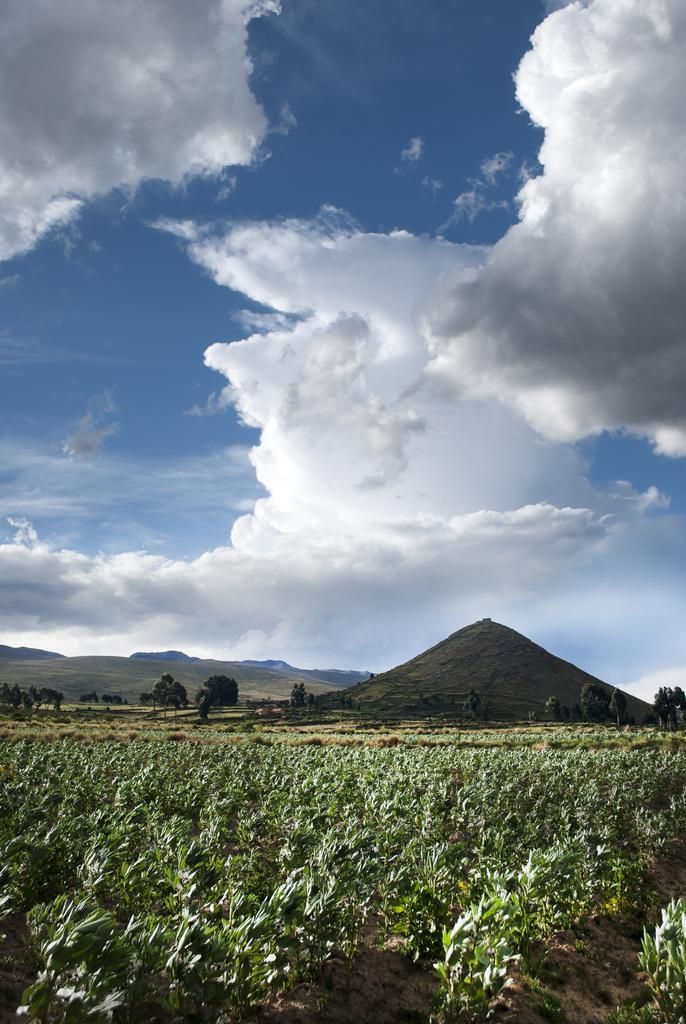What type of landscape is depicted in the image? The image features hills. What type of vegetation can be seen in the image? There are trees and plants in the image. What is visible in the sky at the top of the image? There are clouds in the sky at the top of the image. What type of joke is being told by the boy in the image? There is no boy present in the image, and therefore no joke being told. What color is the boy's hair in the image? There is no boy present in the image, so we cannot determine the color of his hair. 